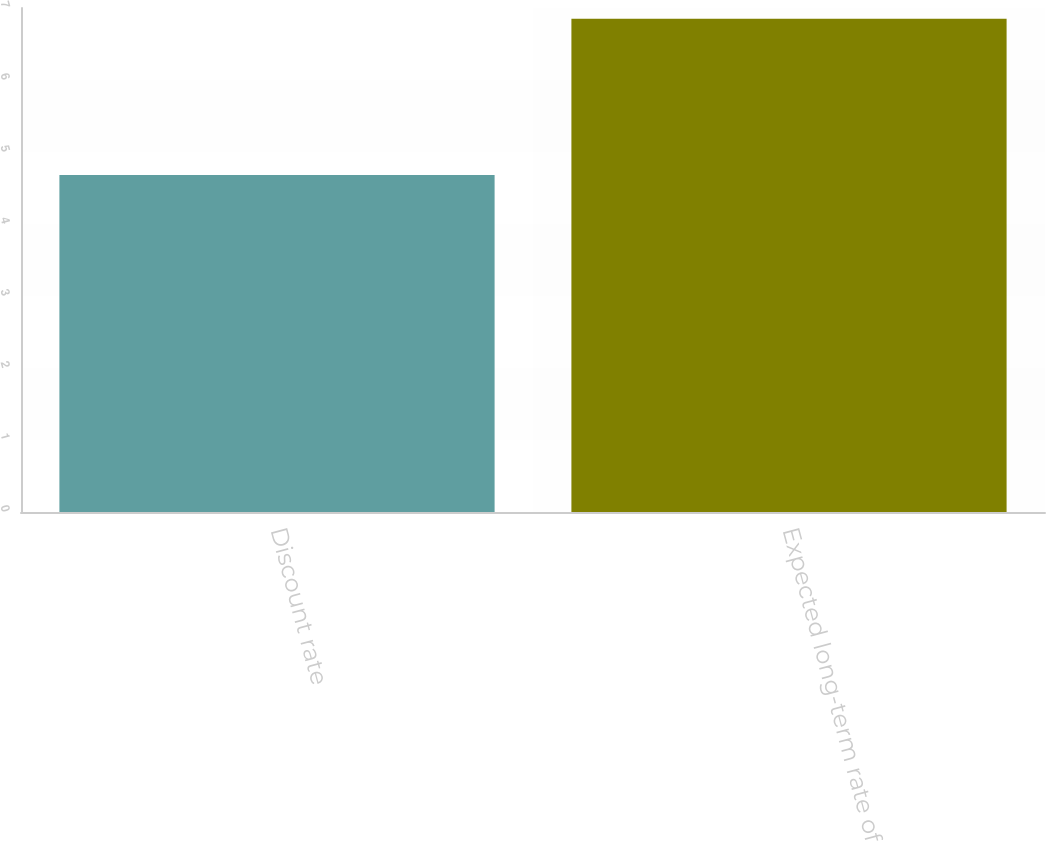Convert chart to OTSL. <chart><loc_0><loc_0><loc_500><loc_500><bar_chart><fcel>Discount rate<fcel>Expected long-term rate of<nl><fcel>4.68<fcel>6.85<nl></chart> 